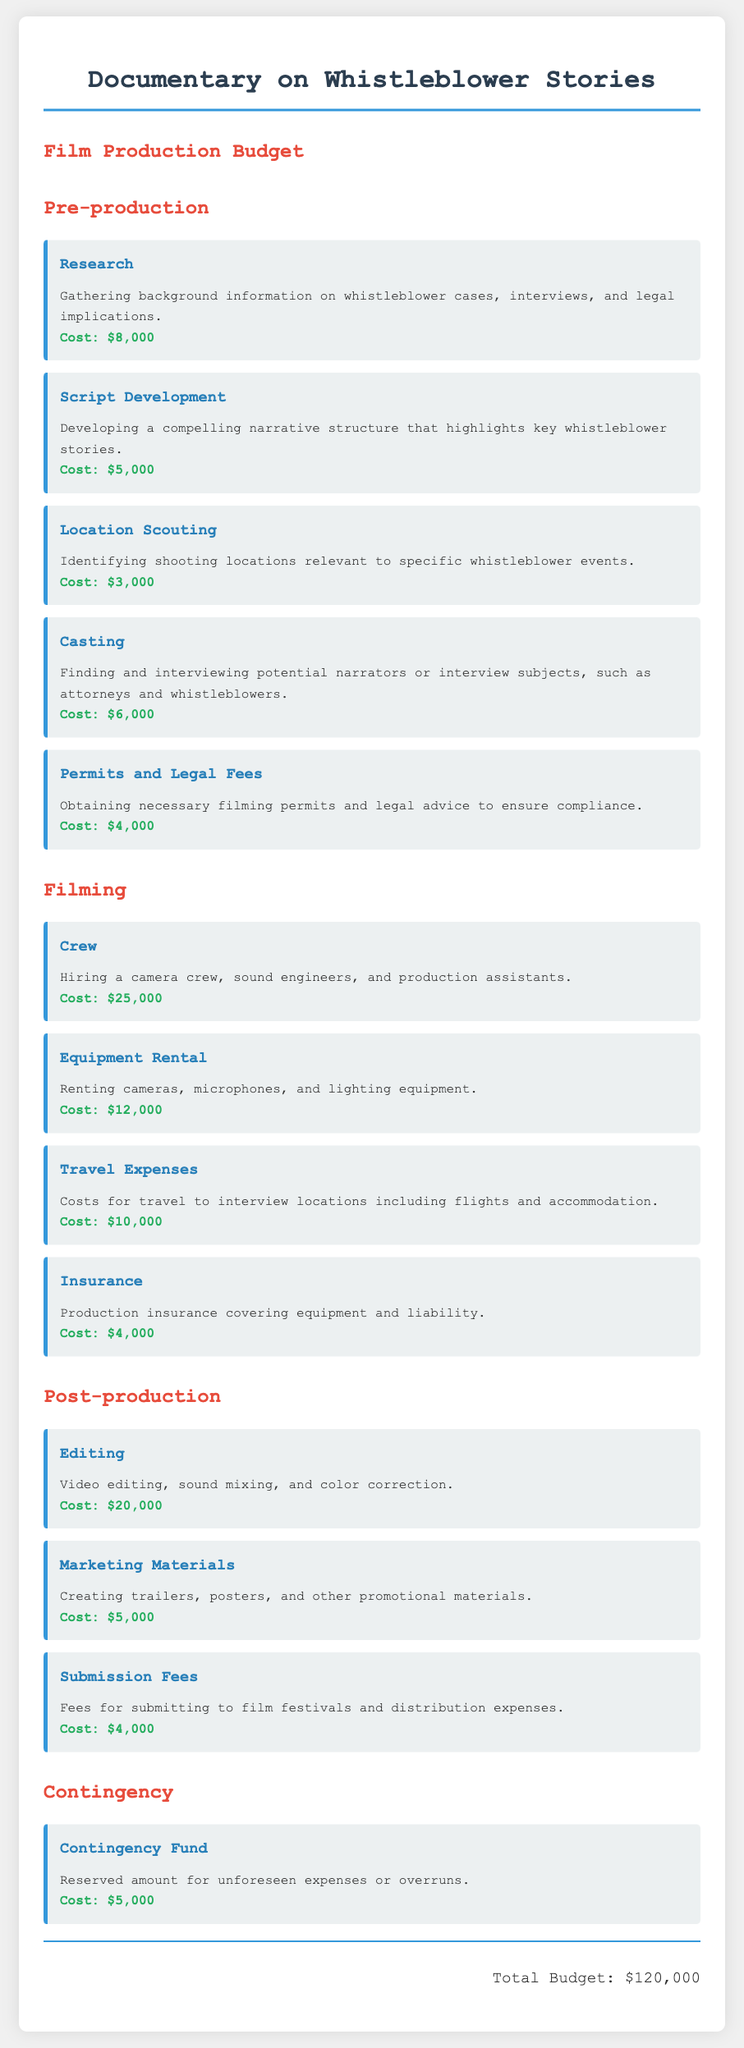What is the total budget for the documentary? The total budget is listed at the end of the document, summing up all expenses, which is $120,000.
Answer: $120,000 How much is allocated for research in pre-production? The budget for research is specified under pre-production costs, which is $8,000.
Answer: $8,000 What is the cost of casting? The casting cost is detailed in the pre-production section, which is $6,000.
Answer: $6,000 What is the budget for travel expenses during filming? The travel expenses are outlined in the filming section, specifically stated as $10,000.
Answer: $10,000 How much is budgeted for editing in post-production? The editing cost can be found in the post-production section, listed as $20,000.
Answer: $20,000 What is the total cost for permits and legal fees? The permits and legal fees are combined under pre-production costs, which totals $4,000.
Answer: $4,000 How much is reserved for the contingency fund? The document specifies a contingency fund for unforeseen expenses, allocated at $5,000.
Answer: $5,000 What is the combined cost of marketing materials and submission fees? The marketing materials cost $5,000 and submission fees cost $4,000, totaling $9,000 together.
Answer: $9,000 What does the crew cost during filming? The crew cost is detailed under filming expenses, which is specified as $25,000.
Answer: $25,000 